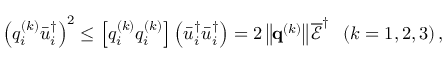<formula> <loc_0><loc_0><loc_500><loc_500>{ \left ( { q _ { i } ^ { \left ( k \right ) } \bar { u } _ { i } ^ { \dag } } \right ) ^ { 2 } } \leq \left [ { q _ { i } ^ { \left ( k \right ) } q _ { i } ^ { \left ( k \right ) } } \right ] \left ( { \bar { u } _ { i } ^ { \dag } \bar { u } _ { i } ^ { \dag } } \right ) = 2 \left \| { { { q } ^ { \left ( k \right ) } } } \right \| \overline { \mathcal { E } } ^ { \dag } \, \left ( { k = 1 , 2 , 3 } \right ) ,</formula> 